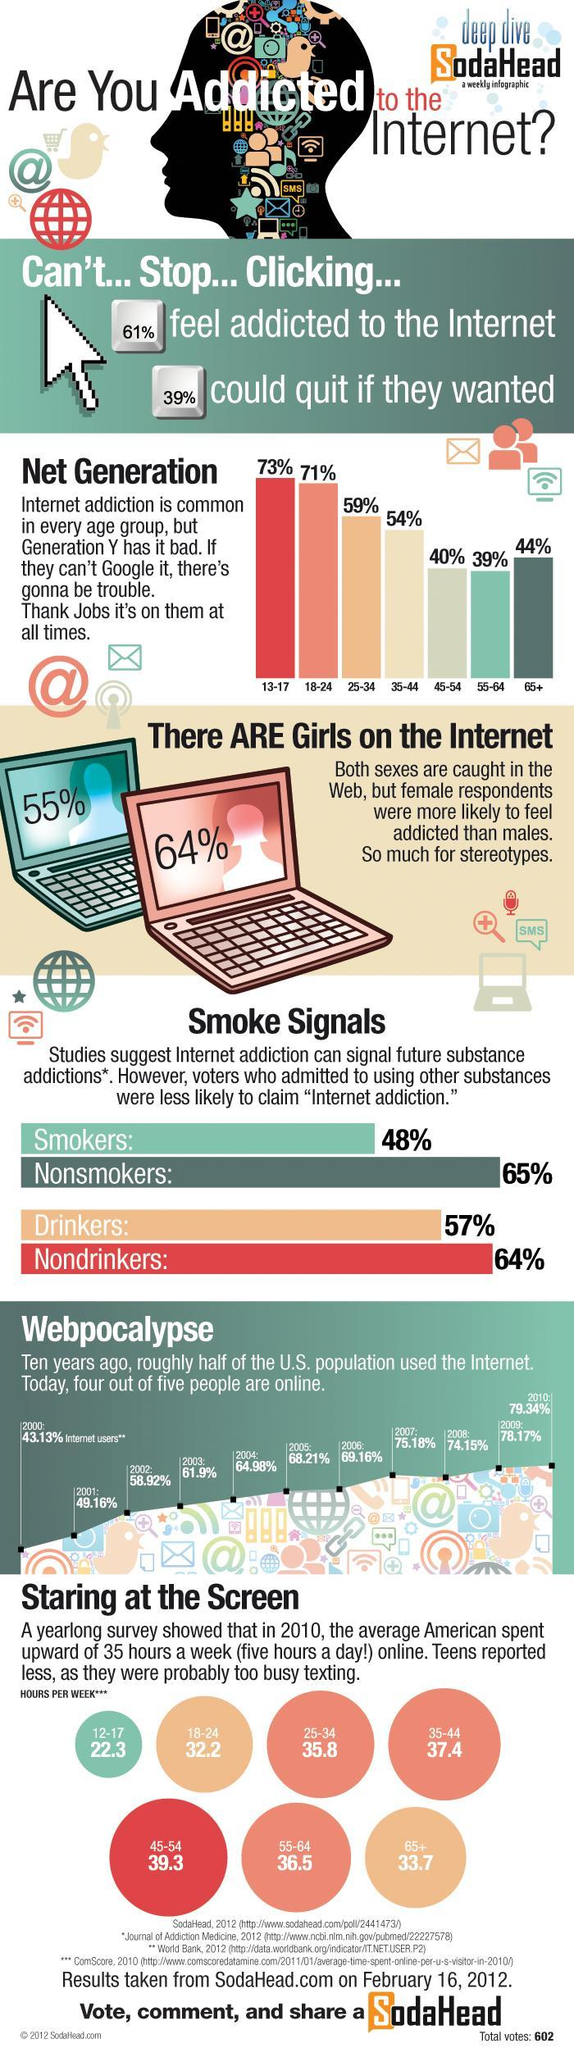What has been the average growth in internet users among the U.S. population from 2006-2010?
Answer the question with a short phrase. 75.192% What percentage of people feel they are not addicted to the internet? 39% What is the percentage of people not wanting to quit internet? 61% What was the percentage of internet users in the U.S. in the year 2004? 64.98% Which age groups spent more than 35 hours on the internet? 35-44, 45-54, 55-64 Which age group is the second highest group of internet users? 18-24 What was the number of hours spent on the internet by the age group 12-17? 22.3 